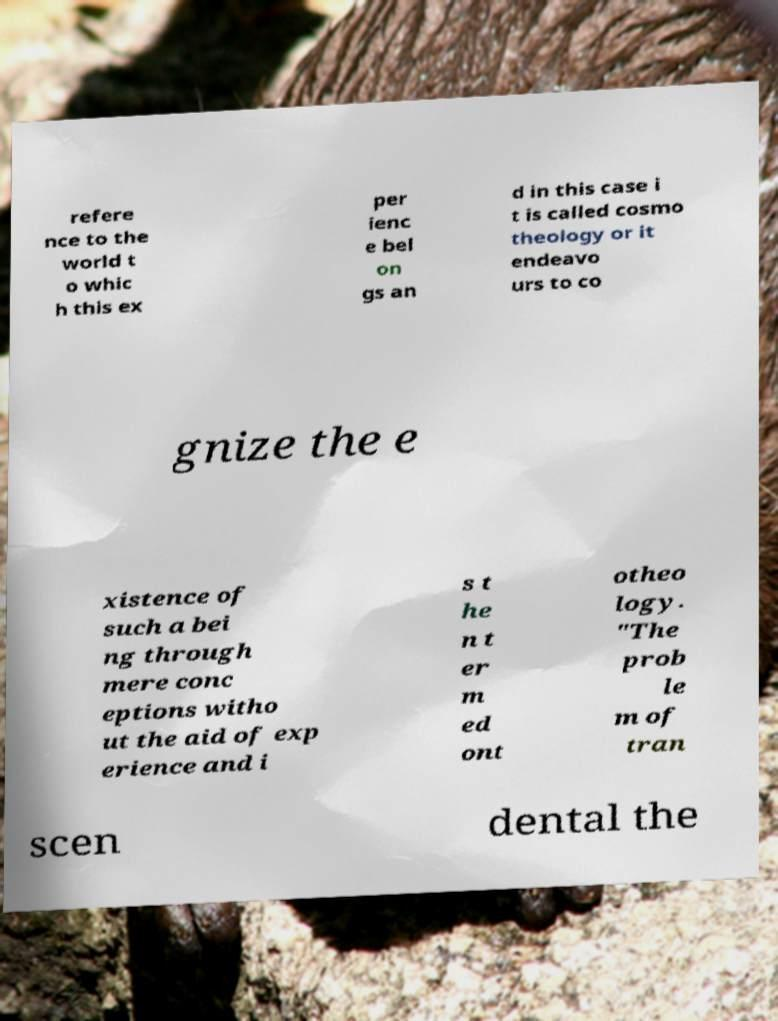Can you read and provide the text displayed in the image?This photo seems to have some interesting text. Can you extract and type it out for me? refere nce to the world t o whic h this ex per ienc e bel on gs an d in this case i t is called cosmo theology or it endeavo urs to co gnize the e xistence of such a bei ng through mere conc eptions witho ut the aid of exp erience and i s t he n t er m ed ont otheo logy. "The prob le m of tran scen dental the 